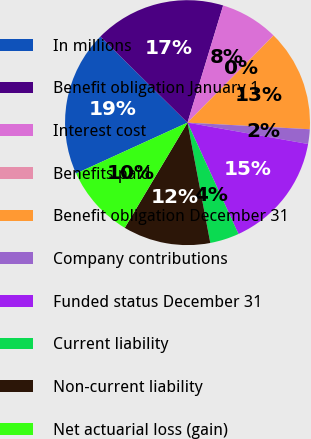Convert chart to OTSL. <chart><loc_0><loc_0><loc_500><loc_500><pie_chart><fcel>In millions<fcel>Benefit obligation January 1<fcel>Interest cost<fcel>Benefits paid<fcel>Benefit obligation December 31<fcel>Company contributions<fcel>Funded status December 31<fcel>Current liability<fcel>Non-current liability<fcel>Net actuarial loss (gain)<nl><fcel>19.22%<fcel>17.3%<fcel>7.69%<fcel>0.01%<fcel>13.46%<fcel>1.93%<fcel>15.38%<fcel>3.85%<fcel>11.54%<fcel>9.62%<nl></chart> 